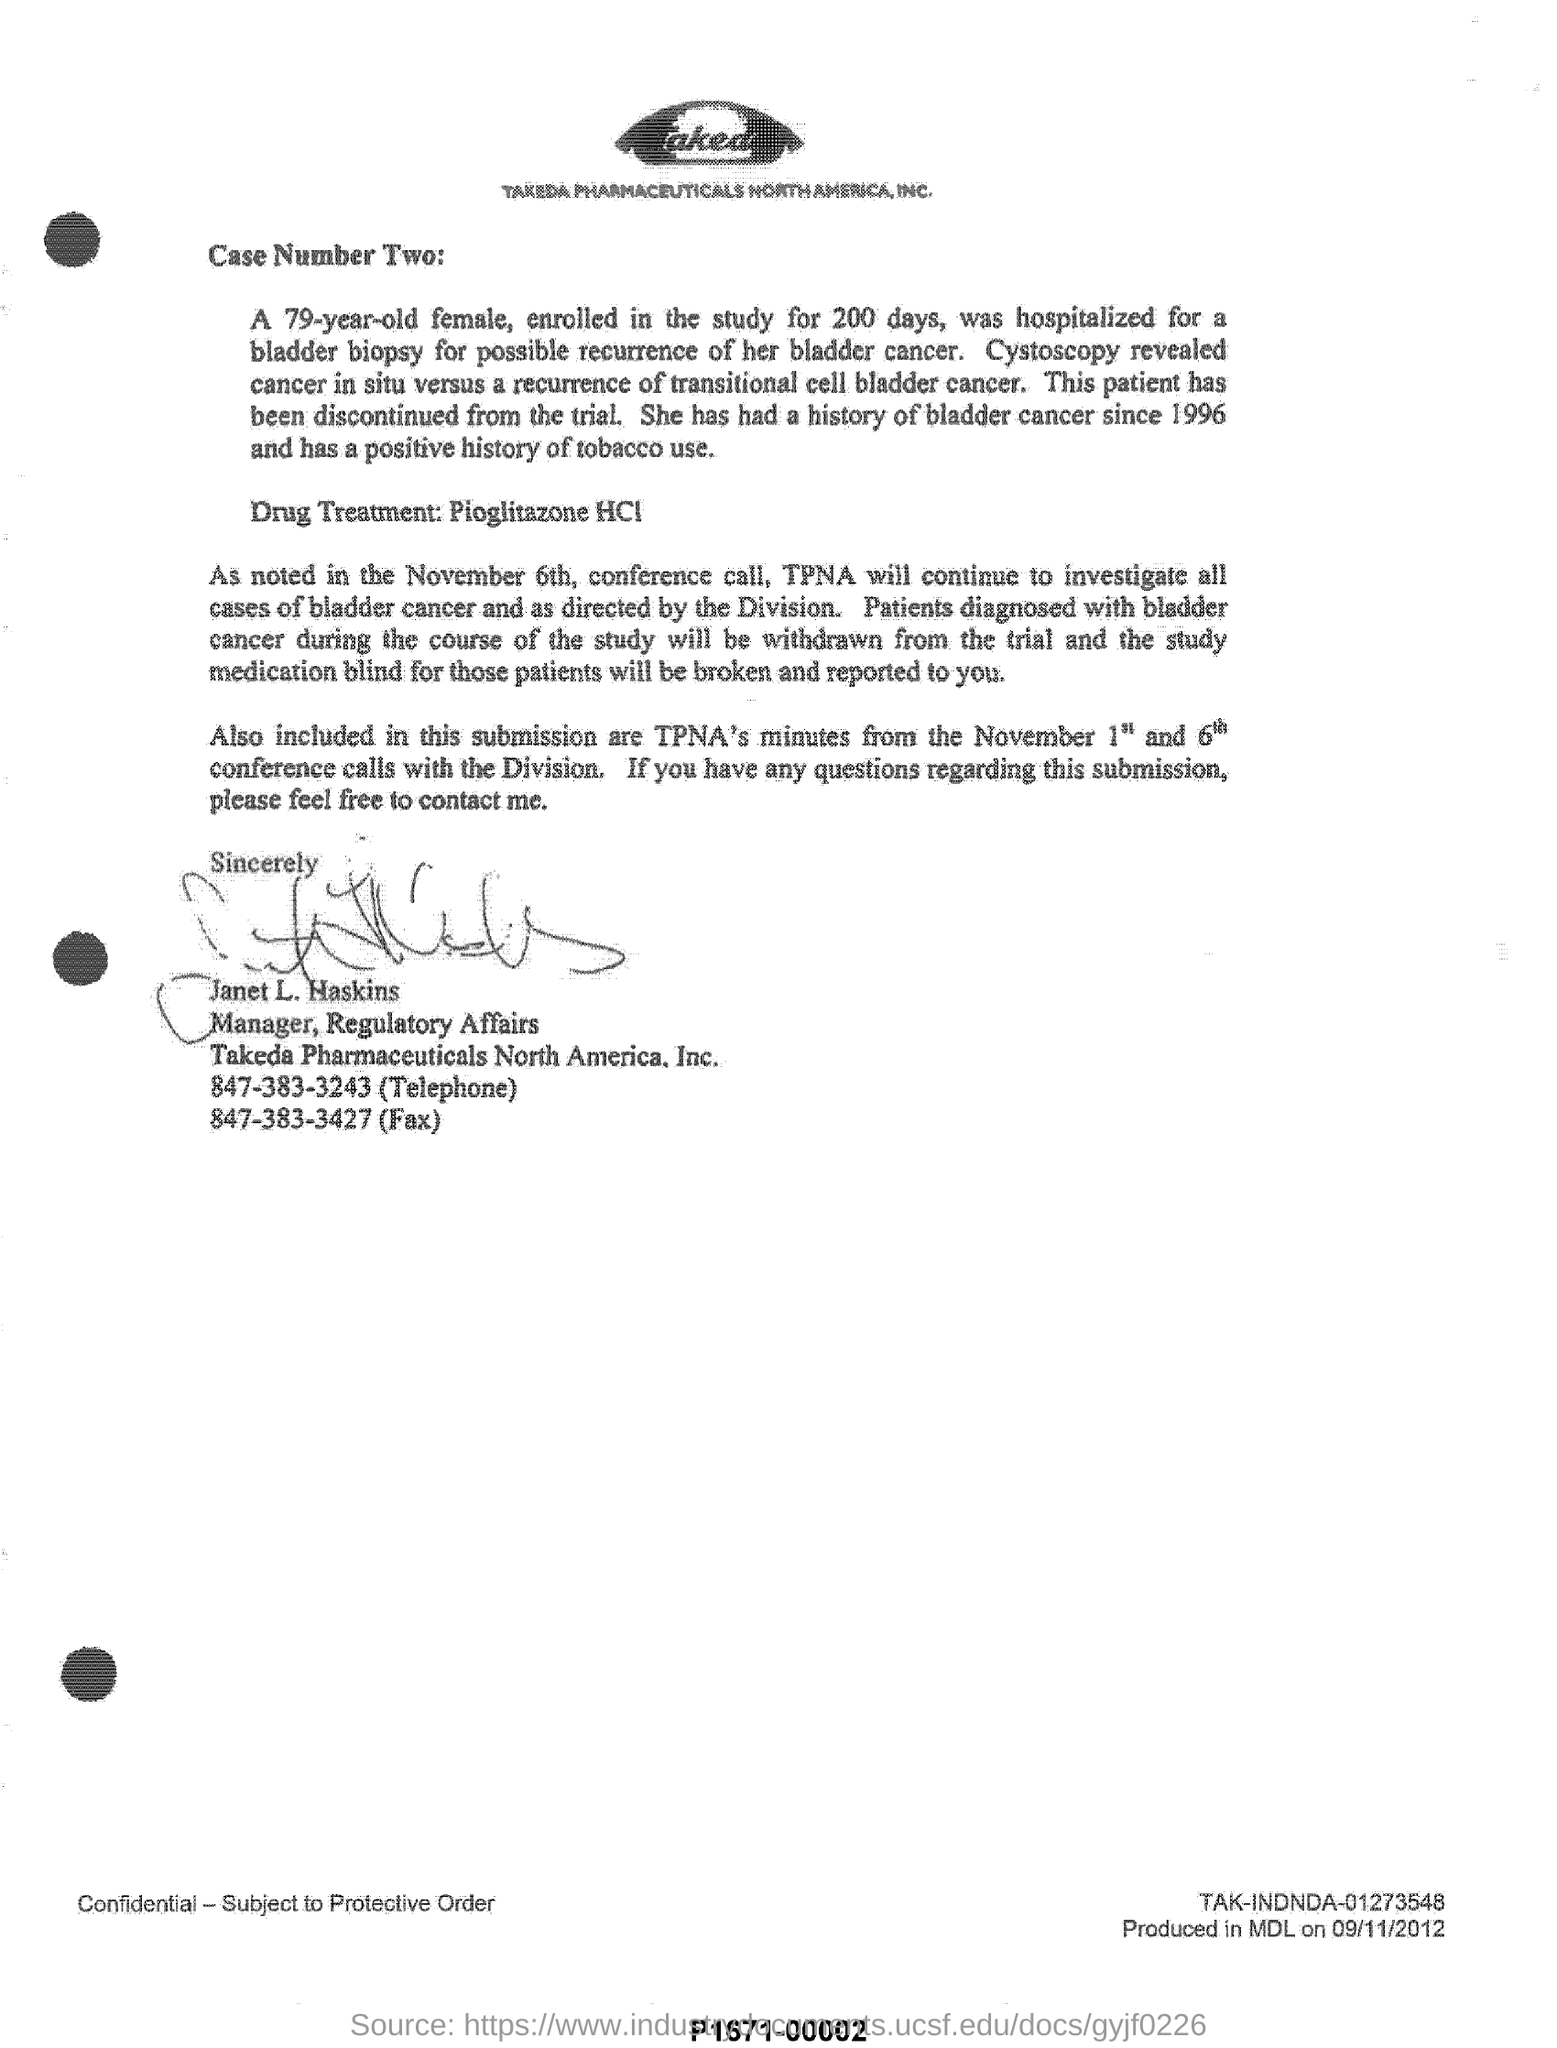A 79-year-old female was enrolled in the study for how many days?
Your answer should be very brief. 200 days. The patient had a history of bladder cancer since when?
Ensure brevity in your answer.  Since 1996. Who is the writer of the document?
Ensure brevity in your answer.  Janet L. Haskins. The woman had a positive history of what?
Provide a short and direct response. Tobacco use. 